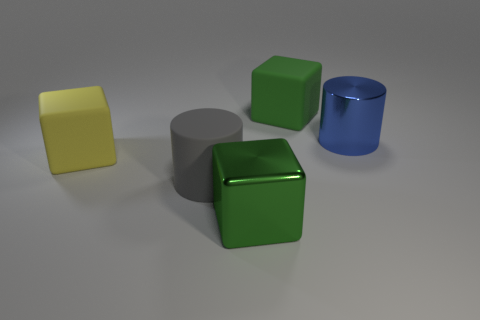Can you describe the lighting and shadows observed in the image? The lighting in the image seems to be coming from the upper left side, casting soft shadows towards the lower right. The objects have subtle highlights and gentle shadows, suggesting a diffuse light source. 